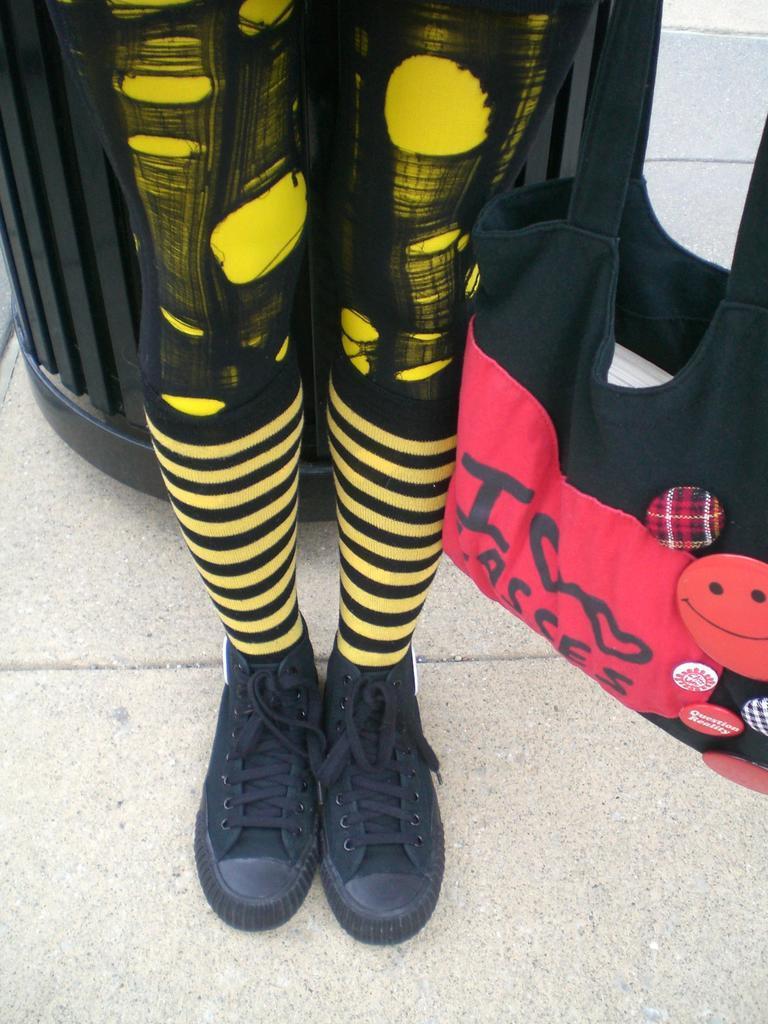Could you give a brief overview of what you see in this image? n this image, in the middle, we can see the legs of a person covered with shoes and the person are standing on the floor. On the right side, we can see a handbag. In the background, we can see a black color box. 